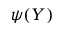<formula> <loc_0><loc_0><loc_500><loc_500>\psi ( Y )</formula> 